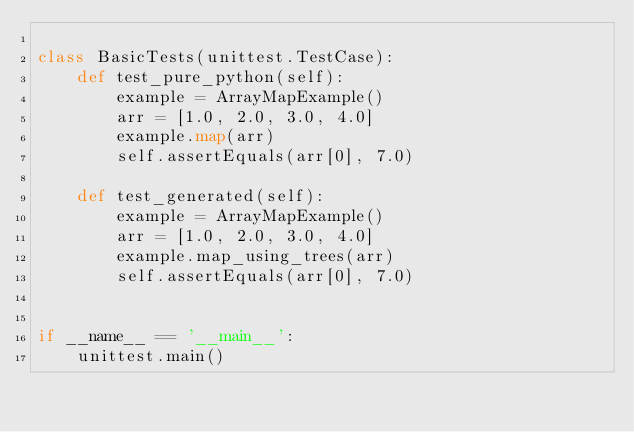<code> <loc_0><loc_0><loc_500><loc_500><_Python_>
class BasicTests(unittest.TestCase):
    def test_pure_python(self):
        example = ArrayMapExample()
        arr = [1.0, 2.0, 3.0, 4.0]
        example.map(arr)
        self.assertEquals(arr[0], 7.0)

    def test_generated(self):
        example = ArrayMapExample()
        arr = [1.0, 2.0, 3.0, 4.0]
        example.map_using_trees(arr)
        self.assertEquals(arr[0], 7.0)


if __name__ == '__main__':
    unittest.main()
</code> 